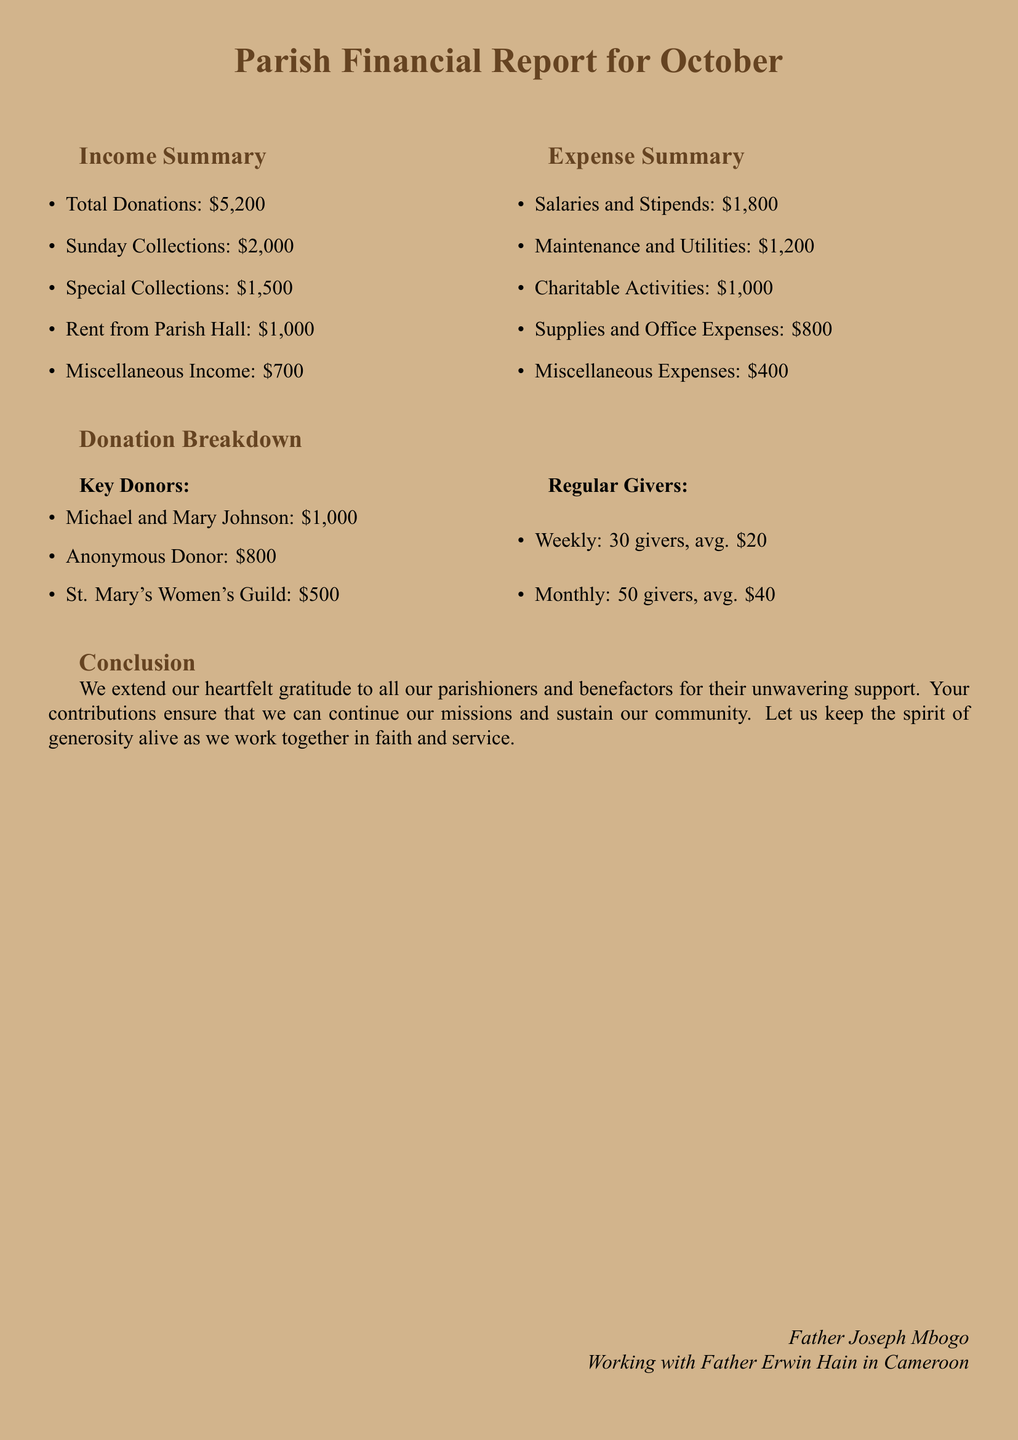What is the total amount of donations? The total amount of donations is listed directly under the Income Summary as total donations.
Answer: $5,200 What is the amount for Sunday Collections? The Sunday Collections amount is provided in the Income Summary section.
Answer: $2,000 Who are the key donors mentioned in the report? The report lists key donors in the Donation Breakdown section.
Answer: Michael and Mary Johnson, Anonymous Donor, St. Mary's Women's Guild What are the total salaries and stipends? The total for salaries and stipends is shown in the Expense Summary section.
Answer: $1,800 How much did the parish earn from Rent from Parish Hall? The income from Rent from Parish Hall is part of the Income Summary.
Answer: $1,000 What is the average donation amount for weekly givers? The average for weekly givers is provided in the Donation Breakdown section.
Answer: $20 What is the total expense for Maintenance and Utilities? The expense for Maintenance and Utilities is detailed in the Expense Summary section.
Answer: $1,200 How many regular monthly givers are there? The number of regular monthly givers is explicitly mentioned in the Donation Breakdown.
Answer: 50 Which category incurred the highest expense? The highest expense category is inferred from the Expense Summary by identifying the highest amount listed.
Answer: Salaries and Stipends What is the total miscellaneous income? The total miscellaneous income is listed in the Income Summary.
Answer: $700 